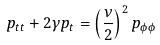<formula> <loc_0><loc_0><loc_500><loc_500>p _ { t t } + 2 \gamma p _ { t } = \left ( \frac { \nu } { 2 } \right ) ^ { 2 } p _ { \phi \phi }</formula> 